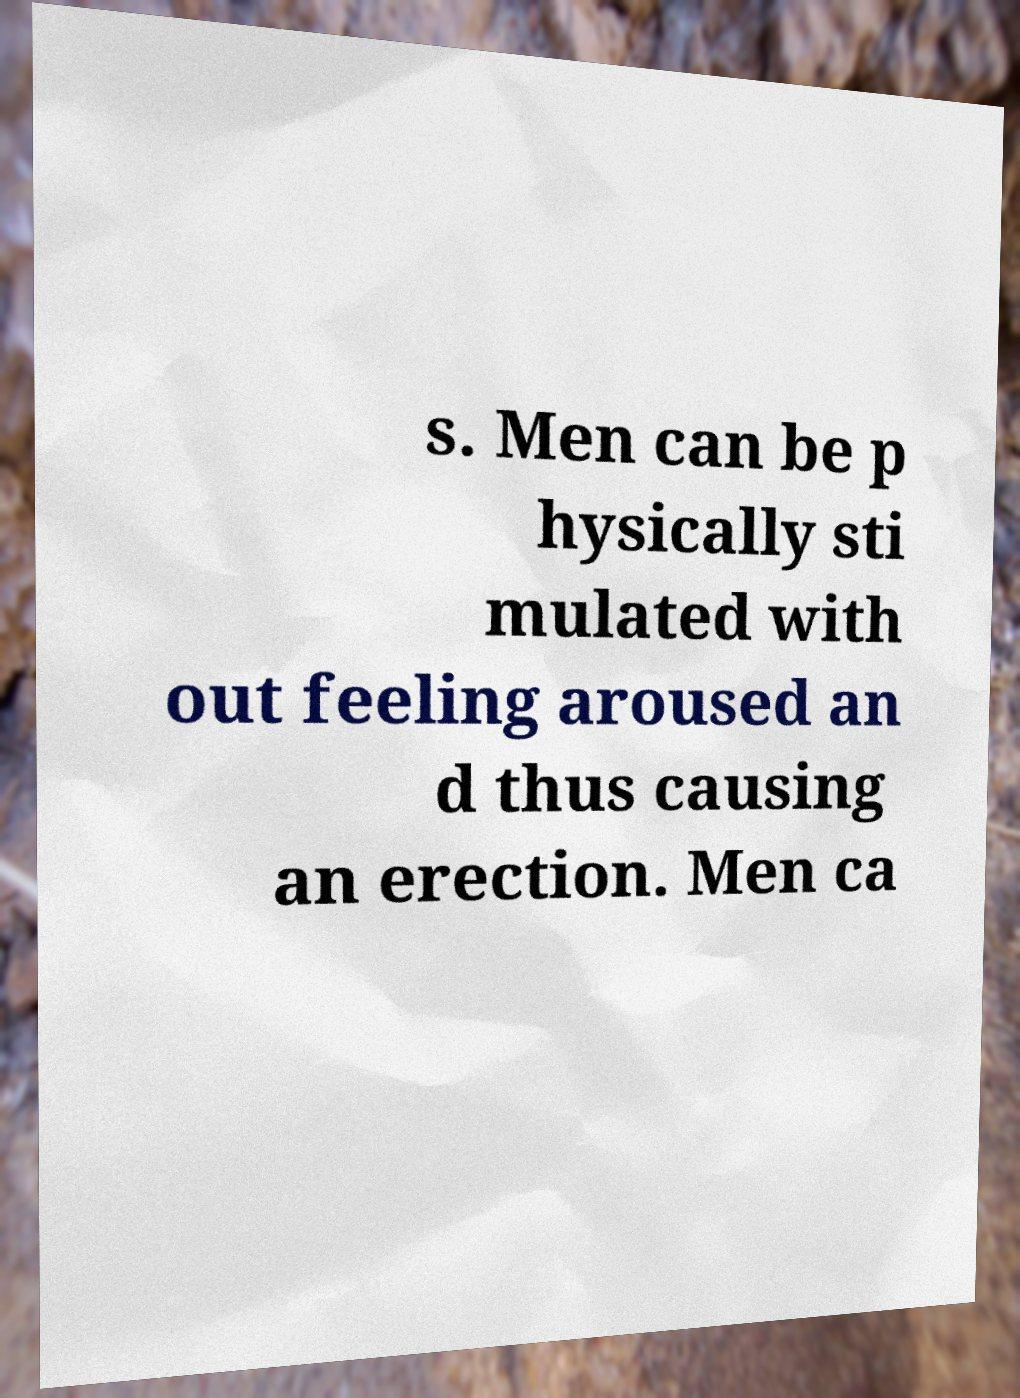Could you assist in decoding the text presented in this image and type it out clearly? s. Men can be p hysically sti mulated with out feeling aroused an d thus causing an erection. Men ca 